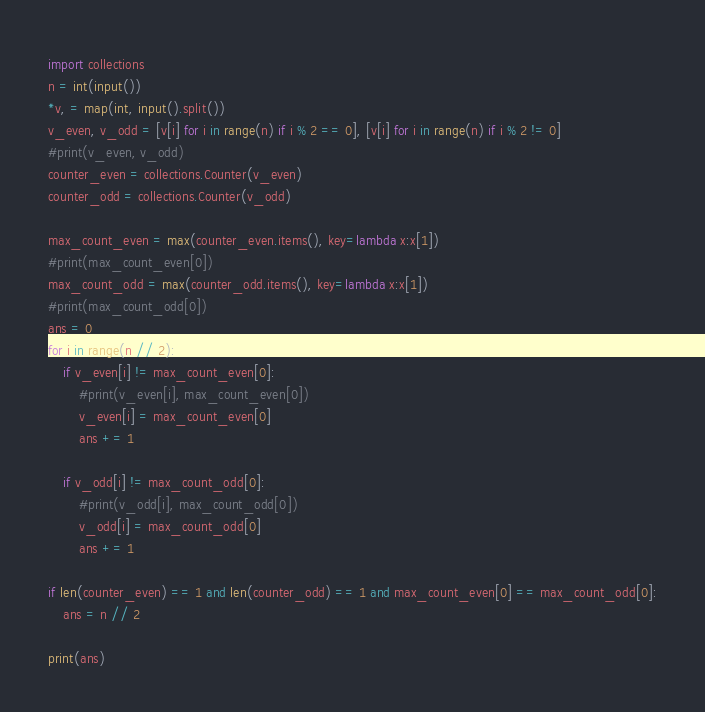<code> <loc_0><loc_0><loc_500><loc_500><_Python_>import collections
n = int(input())
*v, = map(int, input().split())
v_even, v_odd = [v[i] for i in range(n) if i % 2 == 0], [v[i] for i in range(n) if i % 2 != 0]
#print(v_even, v_odd)
counter_even = collections.Counter(v_even)
counter_odd = collections.Counter(v_odd)

max_count_even = max(counter_even.items(), key=lambda x:x[1])
#print(max_count_even[0])
max_count_odd = max(counter_odd.items(), key=lambda x:x[1])
#print(max_count_odd[0])
ans = 0
for i in range(n // 2):
    if v_even[i] != max_count_even[0]:
        #print(v_even[i], max_count_even[0])
        v_even[i] = max_count_even[0]
        ans += 1
        
    if v_odd[i] != max_count_odd[0]:
        #print(v_odd[i], max_count_odd[0])
        v_odd[i] = max_count_odd[0]
        ans += 1

if len(counter_even) == 1 and len(counter_odd) == 1 and max_count_even[0] == max_count_odd[0]:
    ans = n // 2

print(ans)</code> 